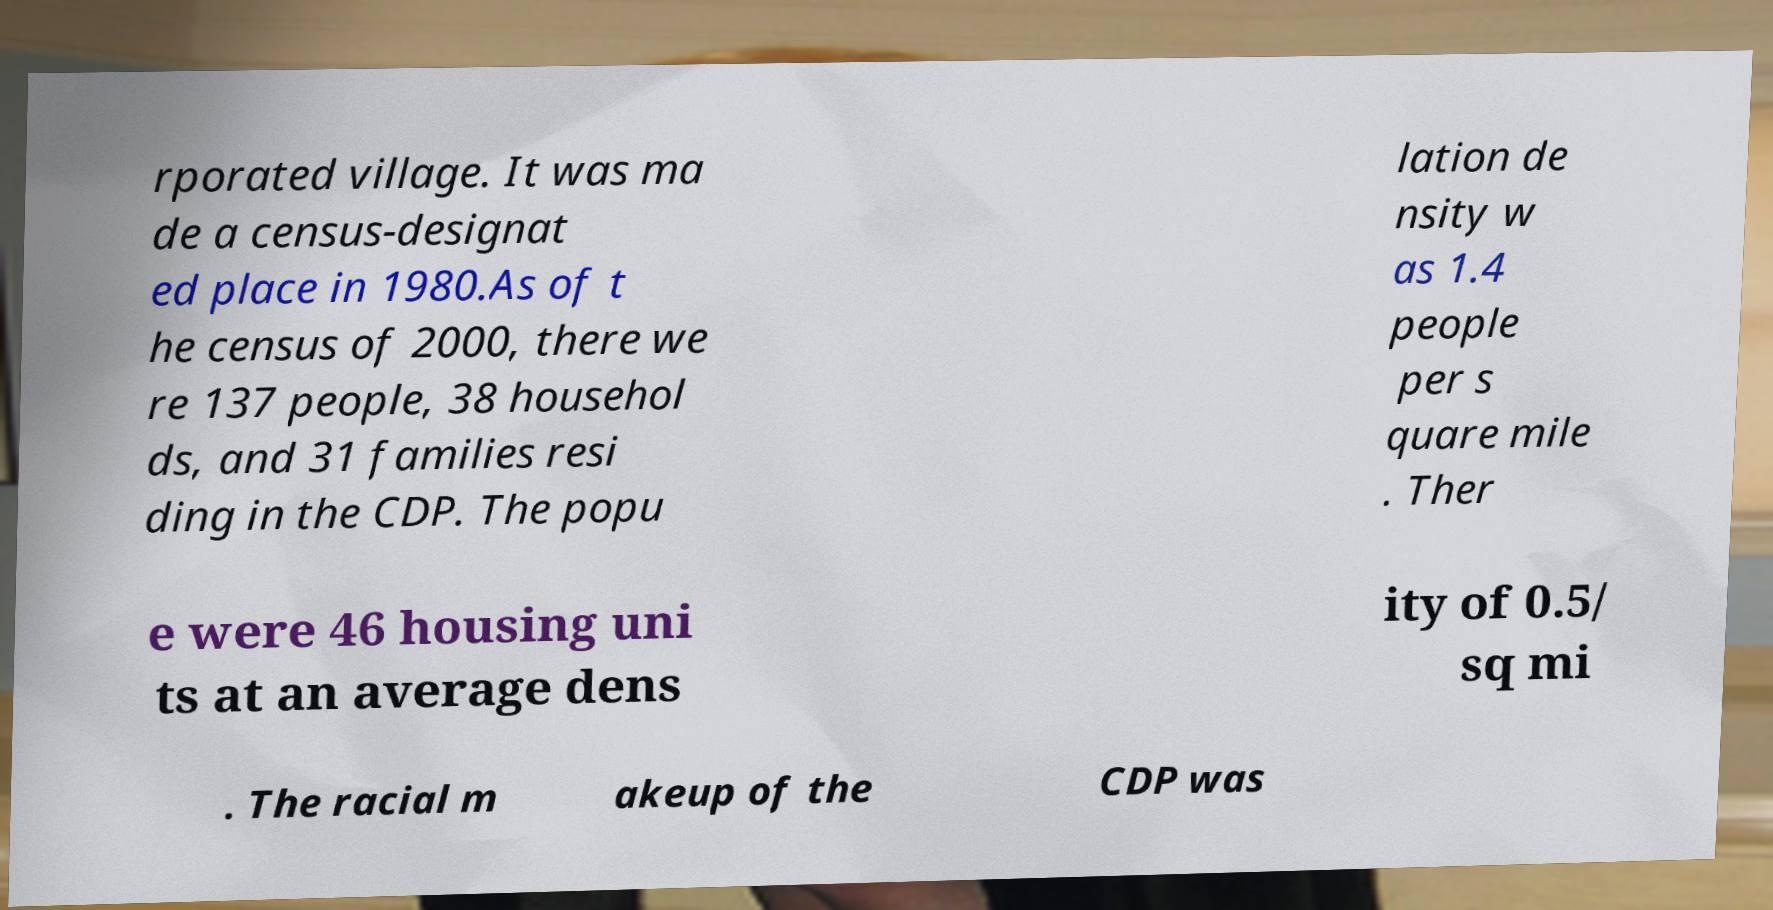Could you extract and type out the text from this image? rporated village. It was ma de a census-designat ed place in 1980.As of t he census of 2000, there we re 137 people, 38 househol ds, and 31 families resi ding in the CDP. The popu lation de nsity w as 1.4 people per s quare mile . Ther e were 46 housing uni ts at an average dens ity of 0.5/ sq mi . The racial m akeup of the CDP was 